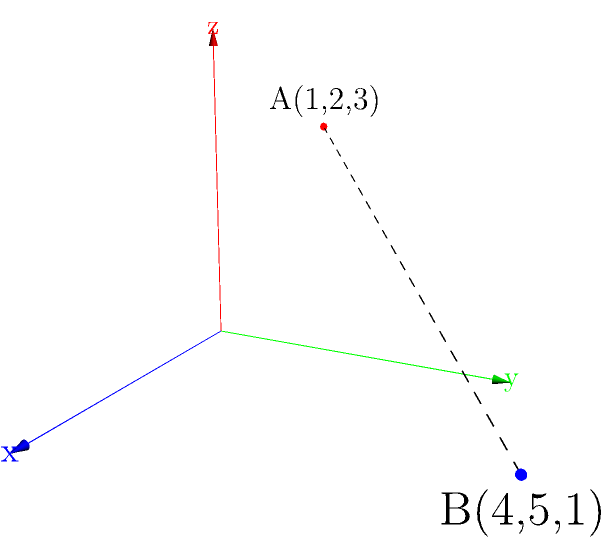You are optimizing server locations for a new cloud infrastructure. Two potential data center locations are represented by points A(1,2,3) and B(4,5,1) in a 3D coordinate system, where each unit represents 100 km. What is the straight-line distance between these two locations in kilometers? To solve this problem, we'll use the distance formula in 3D space and then convert the result to kilometers. Here's the step-by-step process:

1) The distance formula in 3D space is:
   $$d = \sqrt{(x_2-x_1)^2 + (y_2-y_1)^2 + (z_2-z_1)^2}$$

2) We have:
   Point A: $(x_1, y_1, z_1) = (1, 2, 3)$
   Point B: $(x_2, y_2, z_2) = (4, 5, 1)$

3) Let's substitute these values into the formula:
   $$d = \sqrt{(4-1)^2 + (5-2)^2 + (1-3)^2}$$

4) Simplify:
   $$d = \sqrt{3^2 + 3^2 + (-2)^2}$$

5) Calculate:
   $$d = \sqrt{9 + 9 + 4} = \sqrt{22}$$

6) The result is in coordinate units. Since each unit represents 100 km, we multiply by 100:
   $$d_{km} = 100\sqrt{22} \approx 469.04 \text{ km}$$

Therefore, the straight-line distance between the two potential data center locations is approximately 469.04 km.
Answer: 469.04 km 